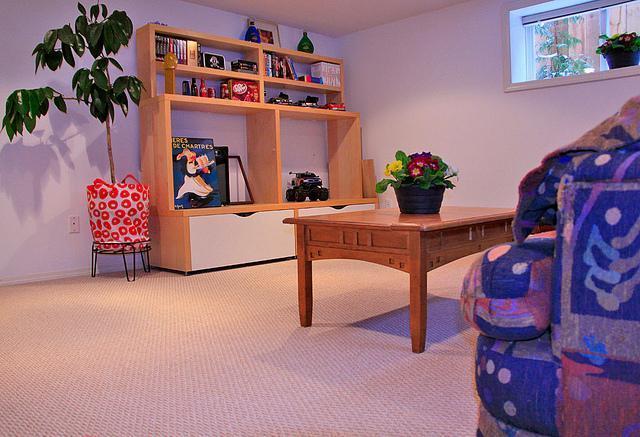Does the image validate the caption "The truck is far from the couch."?
Answer yes or no. Yes. Does the image validate the caption "The truck is under the couch."?
Answer yes or no. No. Does the description: "The truck contains the couch." accurately reflect the image?
Answer yes or no. No. Does the description: "The couch is on top of the truck." accurately reflect the image?
Answer yes or no. No. Does the description: "The truck is beneath the couch." accurately reflect the image?
Answer yes or no. No. Is the caption "The truck is opposite to the couch." a true representation of the image?
Answer yes or no. Yes. Evaluate: Does the caption "The couch is on the truck." match the image?
Answer yes or no. No. 